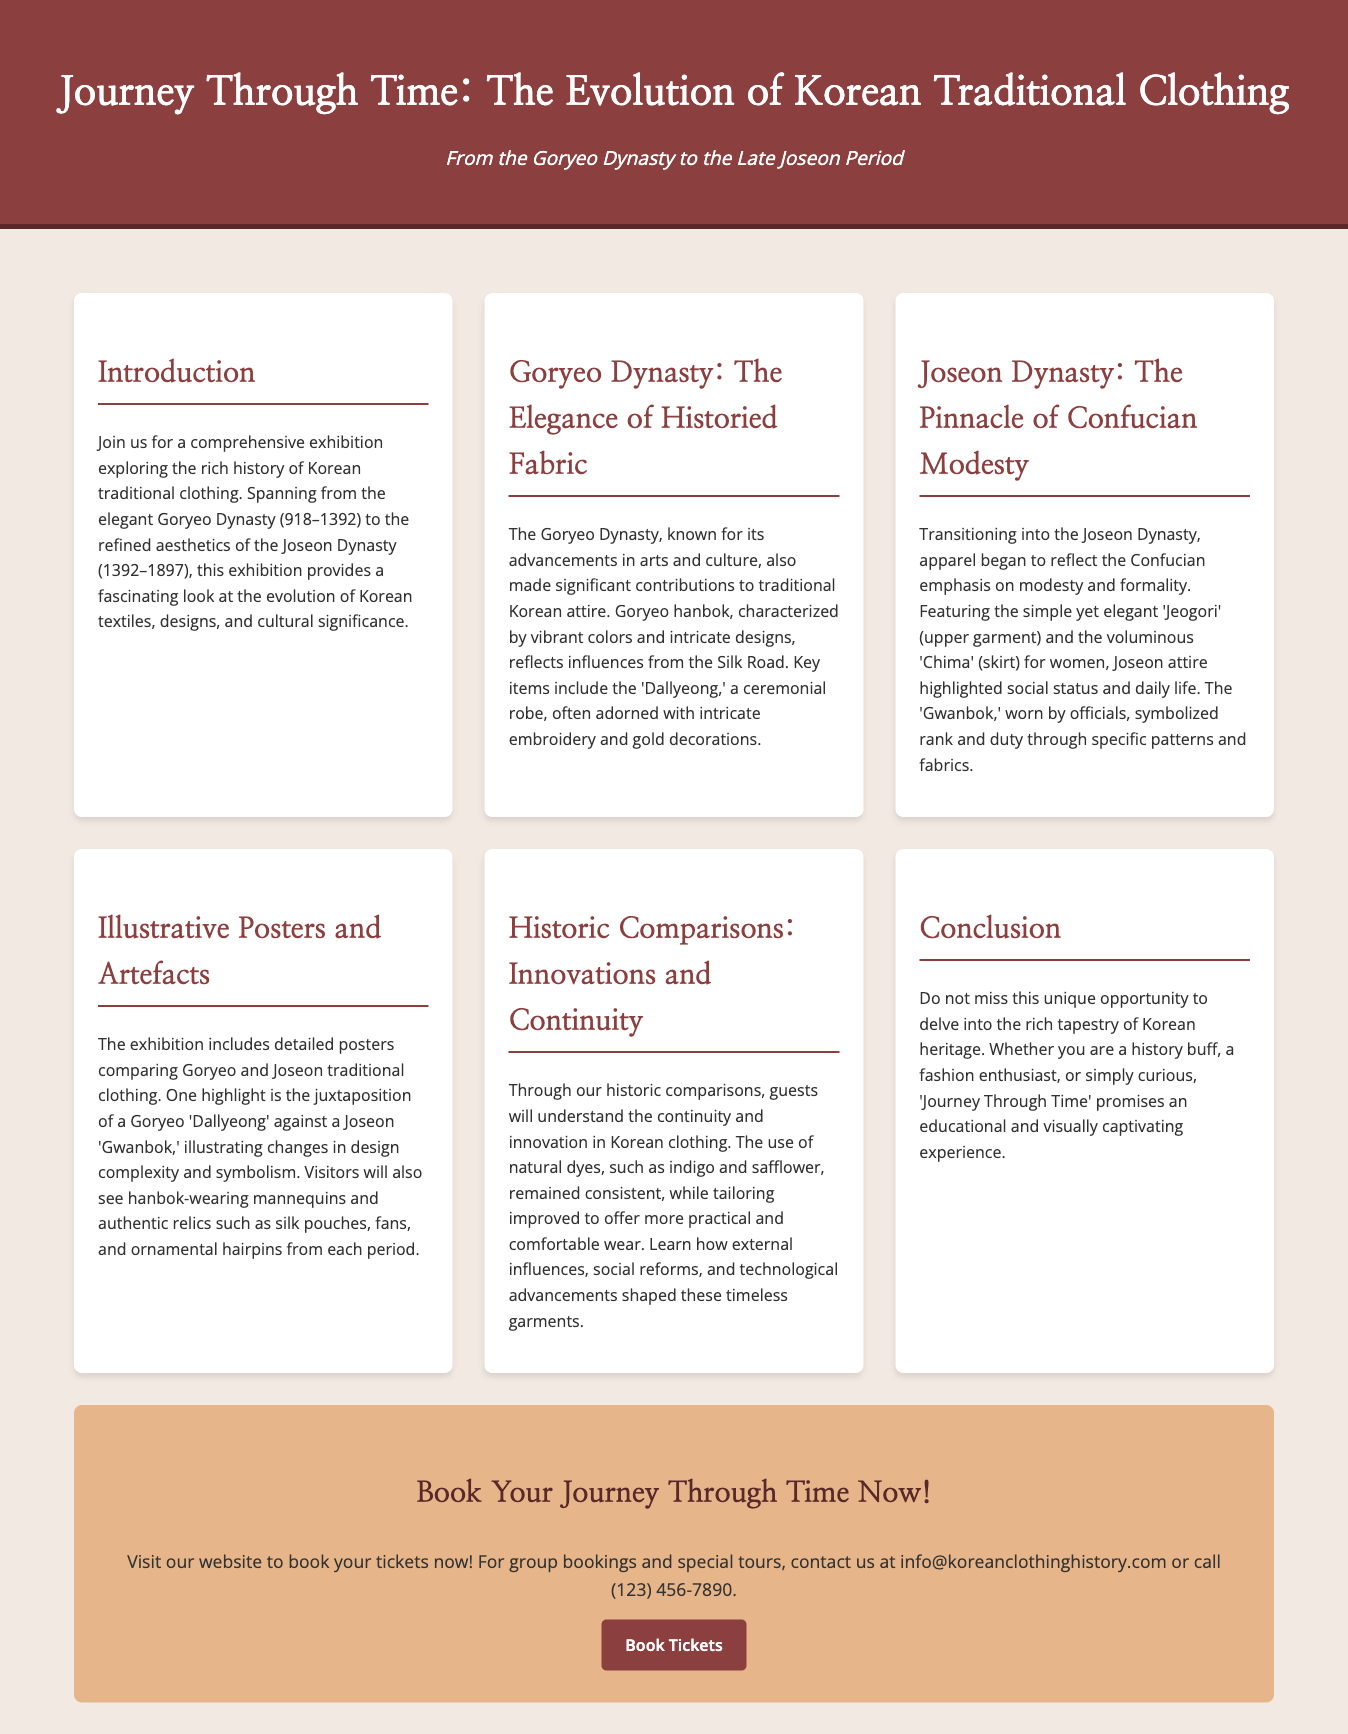What is the title of the exhibition? The title is clearly stated at the top of the document as "Journey Through Time: The Evolution of Korean Traditional Clothing."
Answer: Journey Through Time: The Evolution of Korean Traditional Clothing What are the two main dynasties covered in the exhibition? The exhibition covers the Goryeo Dynasty and the Joseon Dynasty, as mentioned in the introduction.
Answer: Goryeo Dynasty and Joseon Dynasty What key item from the Goryeo Dynasty is highlighted? The document specifies 'Dallyeong,' a ceremonial robe, as a key item from the Goryeo Dynasty.
Answer: Dallyeong What clothing item symbolizes rank and duty in the Joseon Dynasty? The document describes 'Gwanbok' as the clothing item that symbolizes rank and duty during the Joseon Dynasty.
Answer: Gwanbok What is the purpose of the illustrative posters in the exhibition? The posters are used to compare Goryeo and Joseon traditional clothing, providing visual insights into their differences and similarities.
Answer: Compare Goryeo and Joseon traditional clothing What type of experience does the exhibition promise for visitors? The conclusion states that the exhibition promises an educational and visually captivating experience for all visitors.
Answer: Educational and visually captivating What does the call-to-action encourage visitors to do? The call-to-action directly encourages visitors to book their tickets for the exhibition.
Answer: Book your tickets Which email can be used for group bookings? The document provides an email address for group bookings, which is info@koreanclothinghistory.com.
Answer: info@koreanclothinghistory.com What historical aspect does the exhibition focus on? The exhibition focuses on the evolution of Korean traditional clothing, highlighting its historical and cultural significance.
Answer: Evolution of Korean traditional clothing 